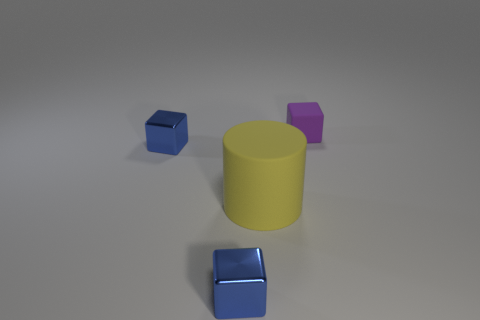Add 3 tiny blue metallic objects. How many objects exist? 7 Subtract all metal blocks. How many blocks are left? 1 Subtract 1 cylinders. How many cylinders are left? 0 Subtract all purple blocks. How many blocks are left? 2 Subtract all green cubes. Subtract all purple balls. How many cubes are left? 3 Subtract 1 yellow cylinders. How many objects are left? 3 Subtract all cubes. How many objects are left? 1 Subtract all gray cubes. How many blue cylinders are left? 0 Subtract all big cylinders. Subtract all blue cubes. How many objects are left? 1 Add 4 blue objects. How many blue objects are left? 6 